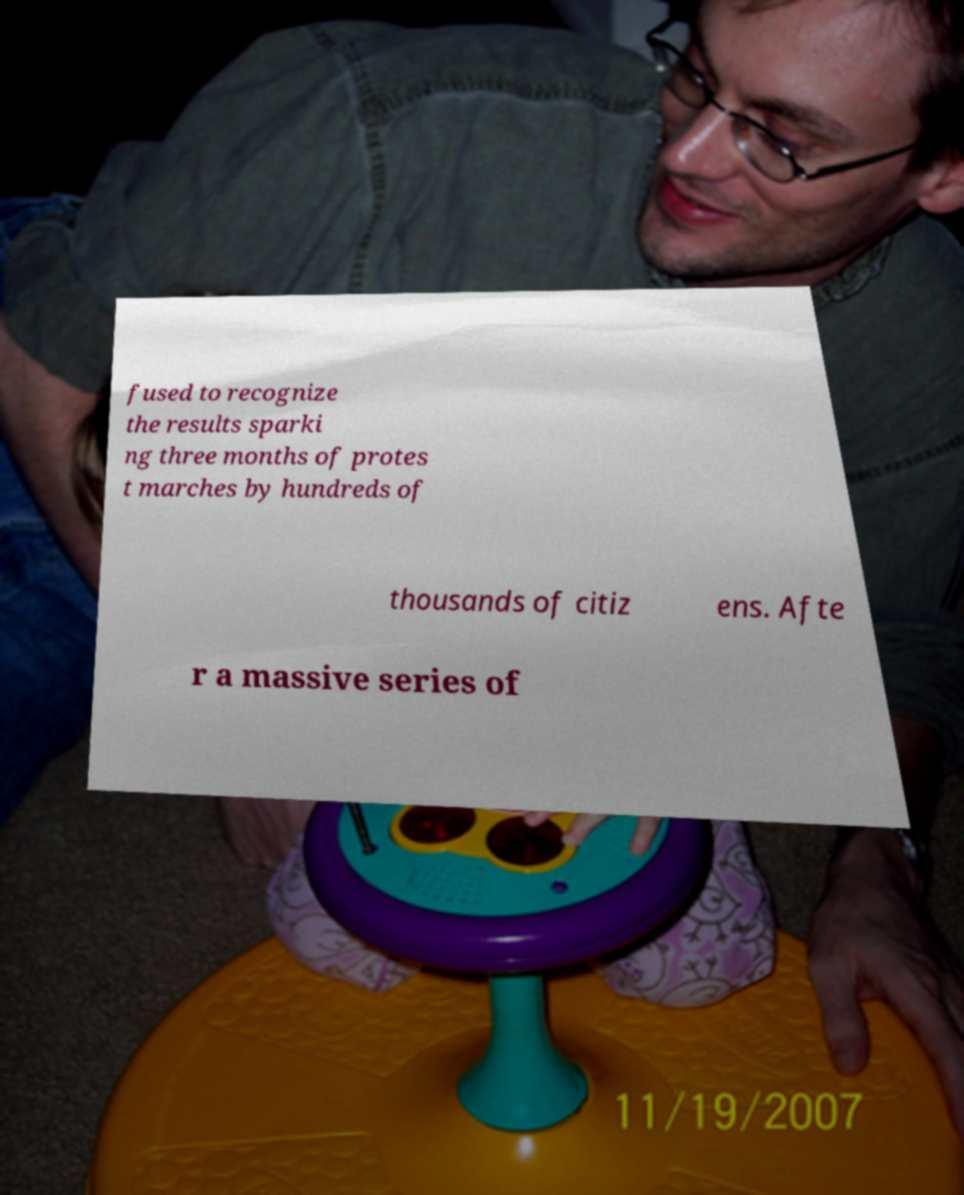Could you assist in decoding the text presented in this image and type it out clearly? fused to recognize the results sparki ng three months of protes t marches by hundreds of thousands of citiz ens. Afte r a massive series of 